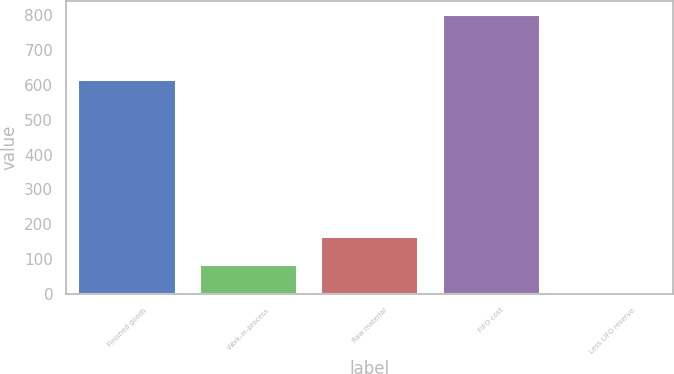<chart> <loc_0><loc_0><loc_500><loc_500><bar_chart><fcel>Finished goods<fcel>Work-in-process<fcel>Raw material<fcel>FIFO cost<fcel>Less LIFO reserve<nl><fcel>614<fcel>83.32<fcel>162.94<fcel>799.9<fcel>3.7<nl></chart> 